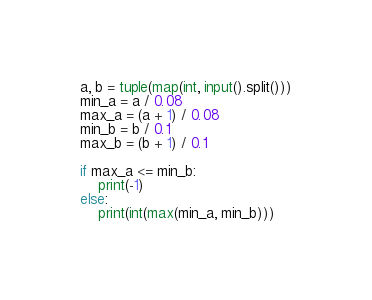<code> <loc_0><loc_0><loc_500><loc_500><_Python_>a, b = tuple(map(int, input().split()))
min_a = a / 0.08
max_a = (a + 1) / 0.08
min_b = b / 0.1
max_b = (b + 1) / 0.1

if max_a <= min_b:
    print(-1)
else:
    print(int(max(min_a, min_b)))
</code> 